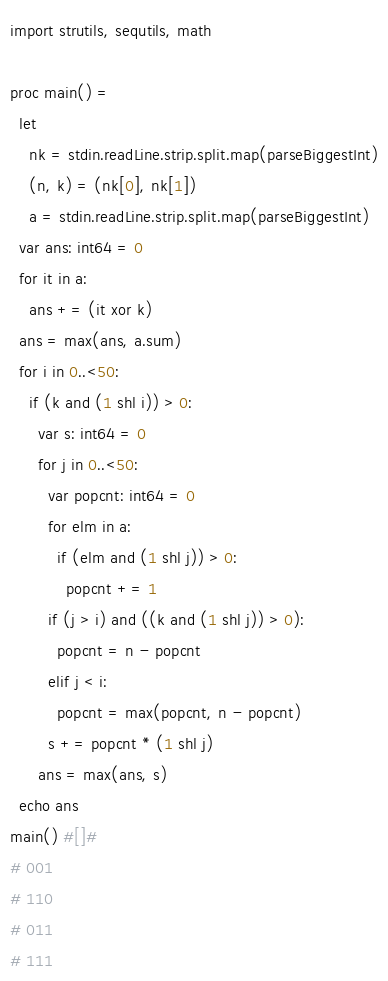Convert code to text. <code><loc_0><loc_0><loc_500><loc_500><_Nim_>import strutils, sequtils, math

proc main() =
  let
    nk = stdin.readLine.strip.split.map(parseBiggestInt)
    (n, k) = (nk[0], nk[1])
    a = stdin.readLine.strip.split.map(parseBiggestInt)
  var ans: int64 = 0
  for it in a:
    ans += (it xor k)
  ans = max(ans, a.sum)
  for i in 0..<50:
    if (k and (1 shl i)) > 0:
      var s: int64 = 0
      for j in 0..<50:
        var popcnt: int64 = 0
        for elm in a:
          if (elm and (1 shl j)) > 0:
            popcnt += 1
        if (j > i) and ((k and (1 shl j)) > 0):
          popcnt = n - popcnt
        elif j < i:
          popcnt = max(popcnt, n - popcnt)
        s += popcnt * (1 shl j)
      ans = max(ans, s)
  echo ans
main() #[]#
# 001
# 110
# 011
# 111
</code> 